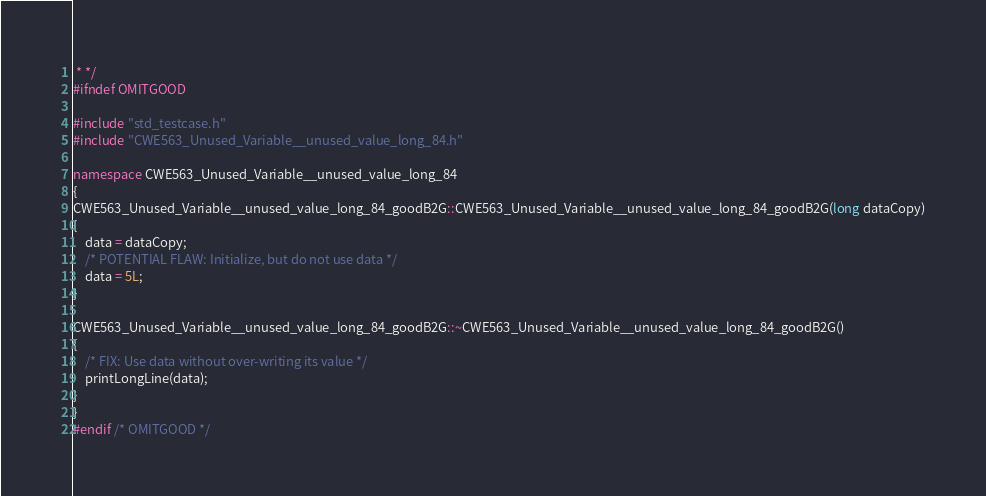<code> <loc_0><loc_0><loc_500><loc_500><_C++_> * */
#ifndef OMITGOOD

#include "std_testcase.h"
#include "CWE563_Unused_Variable__unused_value_long_84.h"

namespace CWE563_Unused_Variable__unused_value_long_84
{
CWE563_Unused_Variable__unused_value_long_84_goodB2G::CWE563_Unused_Variable__unused_value_long_84_goodB2G(long dataCopy)
{
    data = dataCopy;
    /* POTENTIAL FLAW: Initialize, but do not use data */
    data = 5L;
}

CWE563_Unused_Variable__unused_value_long_84_goodB2G::~CWE563_Unused_Variable__unused_value_long_84_goodB2G()
{
    /* FIX: Use data without over-writing its value */
    printLongLine(data);
}
}
#endif /* OMITGOOD */
</code> 